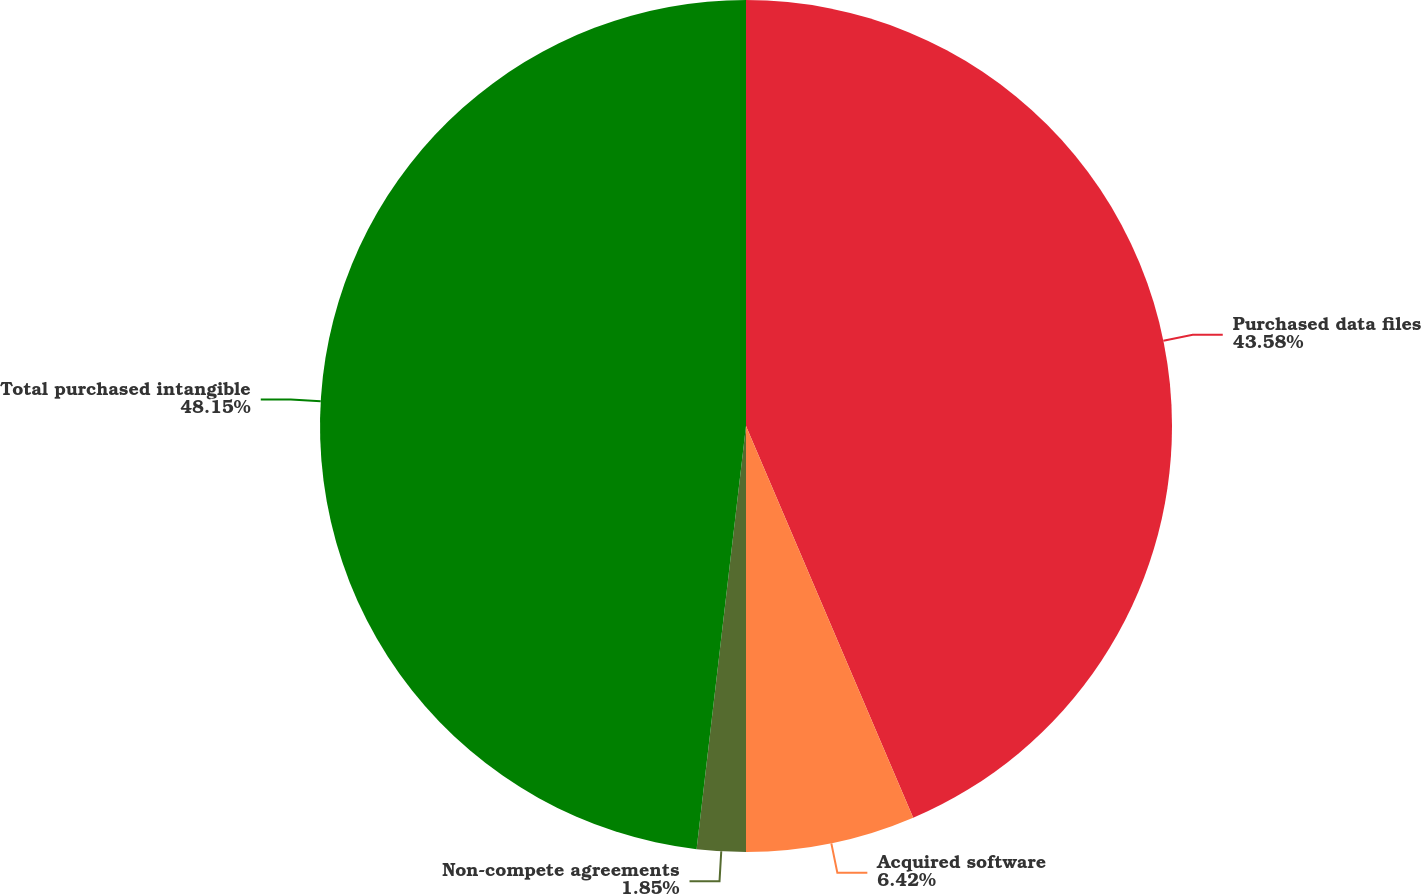Convert chart. <chart><loc_0><loc_0><loc_500><loc_500><pie_chart><fcel>Purchased data files<fcel>Acquired software<fcel>Non-compete agreements<fcel>Total purchased intangible<nl><fcel>43.58%<fcel>6.42%<fcel>1.85%<fcel>48.15%<nl></chart> 